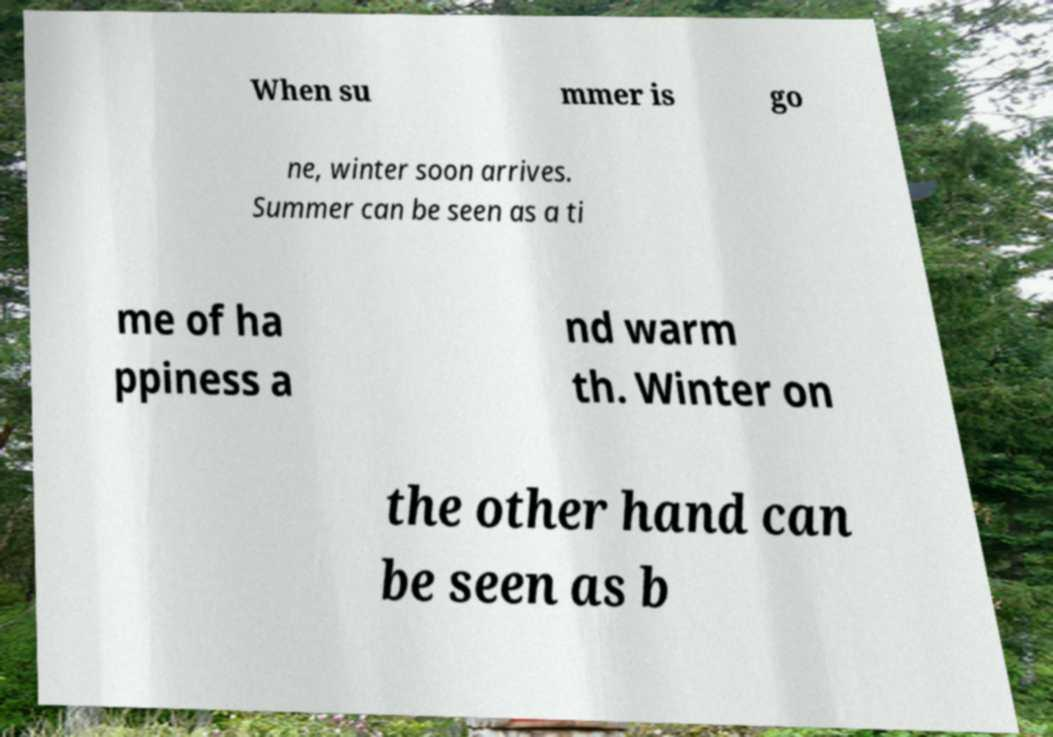Can you read and provide the text displayed in the image?This photo seems to have some interesting text. Can you extract and type it out for me? When su mmer is go ne, winter soon arrives. Summer can be seen as a ti me of ha ppiness a nd warm th. Winter on the other hand can be seen as b 